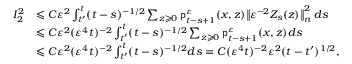Convert formula to latex. <formula><loc_0><loc_0><loc_500><loc_500>\begin{array} { r l } { I _ { 2 } ^ { 2 } } & { \leqslant C \varepsilon ^ { 2 } \int _ { t ^ { \prime } } ^ { t } ( t - s ) ^ { - 1 / 2 } \sum _ { z \geqslant 0 } p _ { t - s + 1 } ^ { \varepsilon } ( x , z ) \left \| \varepsilon ^ { - 2 } Z _ { s } ( z ) \right \| _ { n } ^ { 2 } \, d s } \\ & { \leqslant C \varepsilon ^ { 2 } ( \varepsilon ^ { 4 } t ) ^ { - 2 } \int _ { t ^ { \prime } } ^ { t } ( t - s ) ^ { - 1 / 2 } \sum _ { z \geqslant 0 } p _ { t - s + 1 } ^ { \varepsilon } ( x , z ) d s } \\ & { \leqslant C \varepsilon ^ { 2 } ( \varepsilon ^ { 4 } t ) ^ { - 2 } \int _ { t ^ { \prime } } ^ { t } ( t - s ) ^ { - 1 / 2 } d s = C ( \varepsilon ^ { 4 } t ) ^ { - 2 } \varepsilon ^ { 2 } ( t - t ^ { \prime } ) ^ { 1 / 2 } , } \end{array}</formula> 